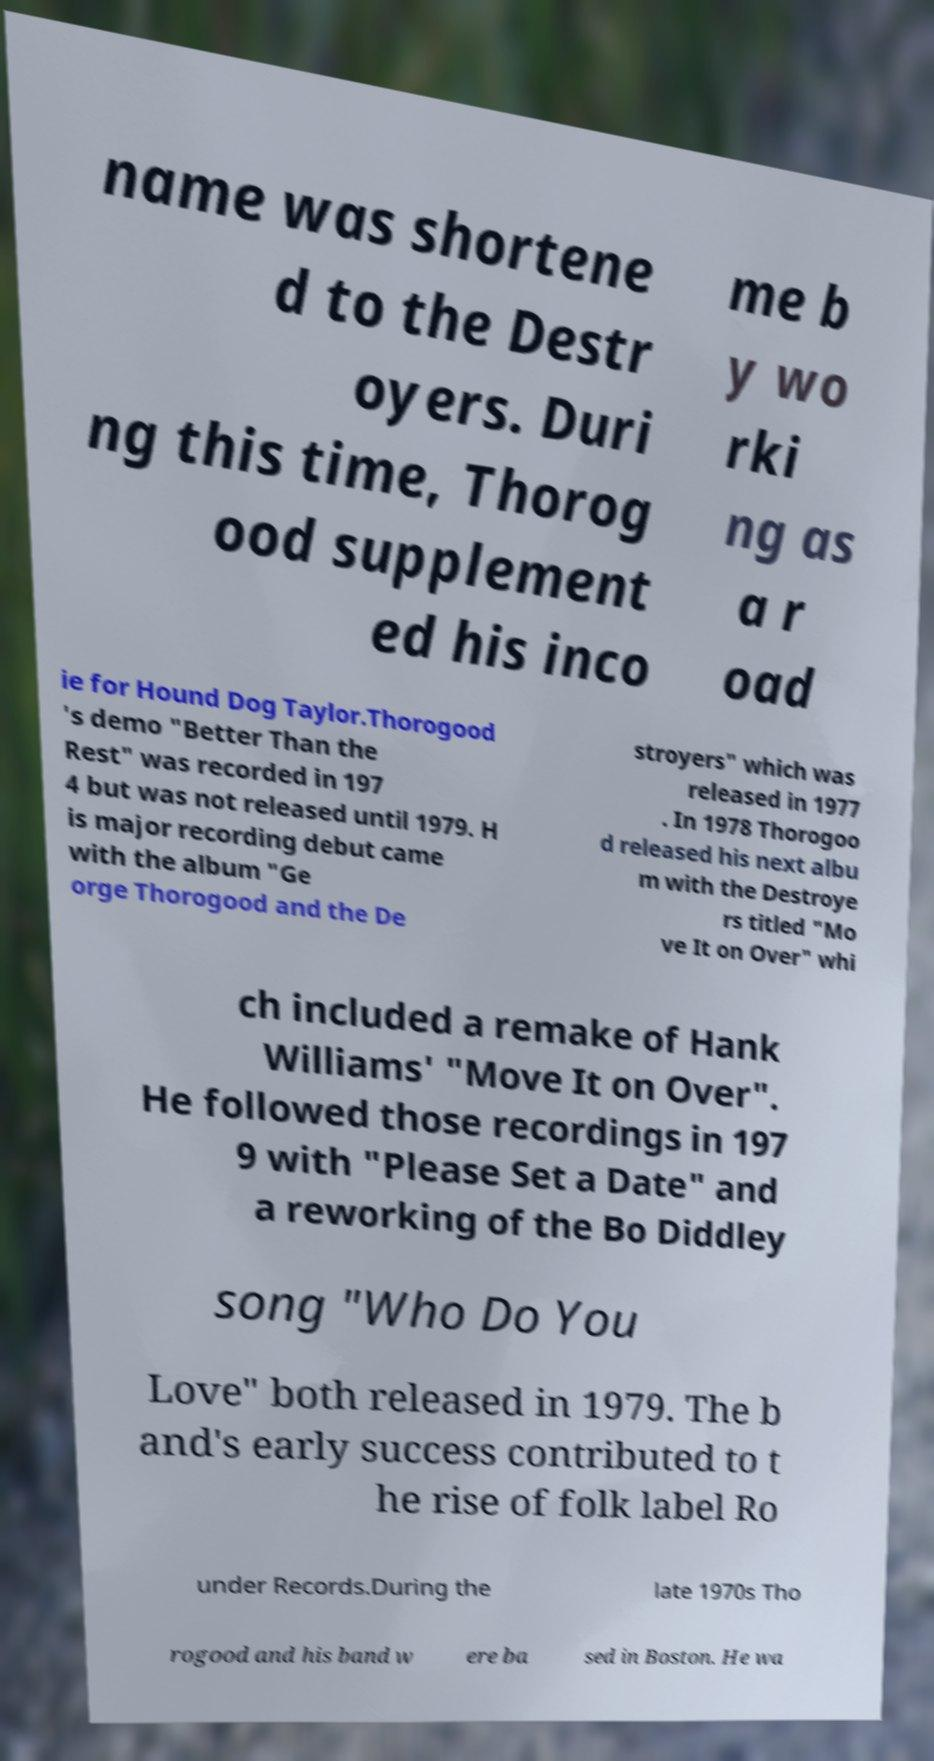I need the written content from this picture converted into text. Can you do that? name was shortene d to the Destr oyers. Duri ng this time, Thorog ood supplement ed his inco me b y wo rki ng as a r oad ie for Hound Dog Taylor.Thorogood 's demo "Better Than the Rest" was recorded in 197 4 but was not released until 1979. H is major recording debut came with the album "Ge orge Thorogood and the De stroyers" which was released in 1977 . In 1978 Thorogoo d released his next albu m with the Destroye rs titled "Mo ve It on Over" whi ch included a remake of Hank Williams' "Move It on Over". He followed those recordings in 197 9 with "Please Set a Date" and a reworking of the Bo Diddley song "Who Do You Love" both released in 1979. The b and's early success contributed to t he rise of folk label Ro under Records.During the late 1970s Tho rogood and his band w ere ba sed in Boston. He wa 